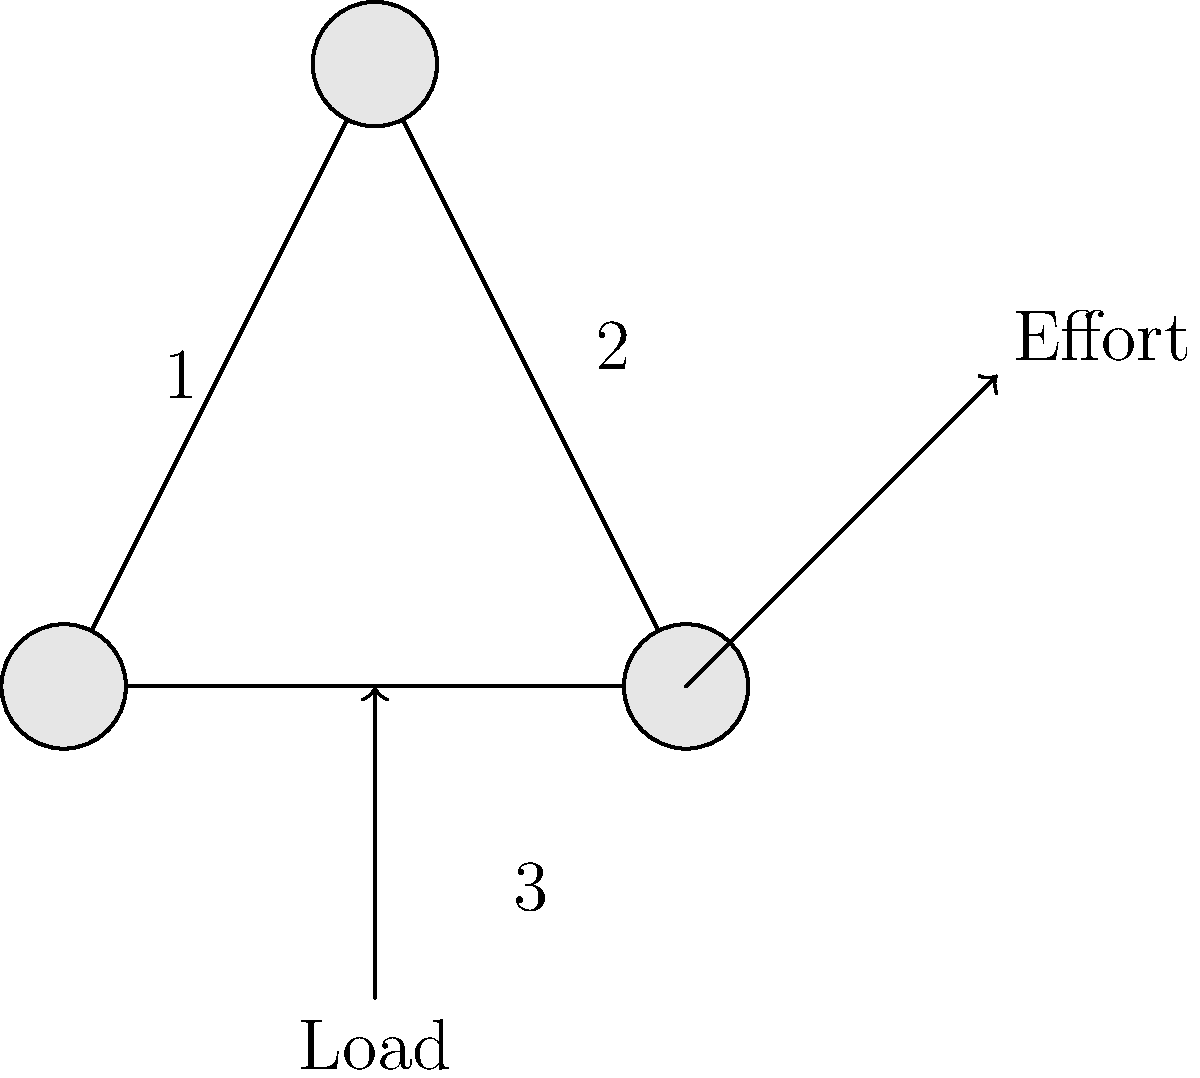In a Celtic-inspired engineering challenge, you're tasked with designing a pulley system to lift heavy stones for a monument. The system consists of three ropes as shown in the diagram. If the load is 600 N, what is the effort required to lift it, assuming the system is ideal with no friction? How does this demonstrate the value of teamwork in engineering? Let's approach this step-by-step, much like building a strong Celtic squad:

1) First, we need to understand the concept of mechanical advantage (MA) in a pulley system. The MA is the ratio of the load to the effort:

   $MA = \frac{Load}{Effort}$

2) In an ideal pulley system, the MA is equal to the number of rope segments supporting the load.

3) Looking at our diagram, we can see:
   - Rope 1 supports the load
   - Rope 2 supports the load
   - Rope 3 directly lifts the load

   So, there are 3 rope segments supporting the load.

4) Therefore, the mechanical advantage of this system is 3:

   $MA = 3$

5) Now, we can use the MA formula to find the effort:

   $3 = \frac{600 N}{Effort}$

6) Solving for Effort:

   $Effort = \frac{600 N}{3} = 200 N$

This system demonstrates teamwork in engineering as each rope contributes to supporting the load, just as each player in a Celtic squad contributes to the team's success. The combined effort of the ropes (or team members) allows for a much heavier load to be lifted with less individual effort.
Answer: 200 N 